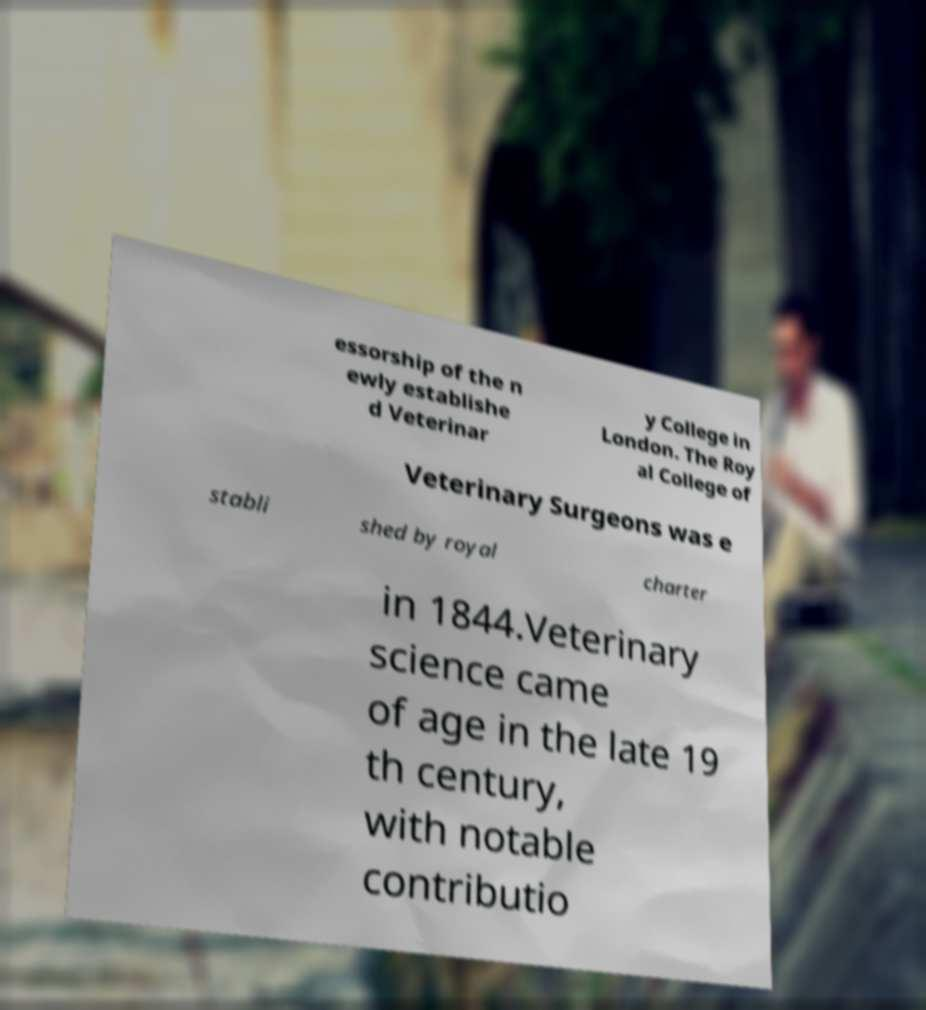Could you assist in decoding the text presented in this image and type it out clearly? essorship of the n ewly establishe d Veterinar y College in London. The Roy al College of Veterinary Surgeons was e stabli shed by royal charter in 1844.Veterinary science came of age in the late 19 th century, with notable contributio 